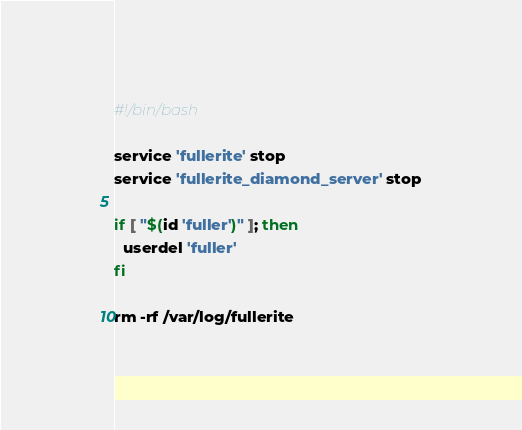<code> <loc_0><loc_0><loc_500><loc_500><_Bash_>#!/bin/bash

service 'fullerite' stop
service 'fullerite_diamond_server' stop

if [ "$(id 'fuller')" ]; then
  userdel 'fuller'
fi

rm -rf /var/log/fullerite
</code> 